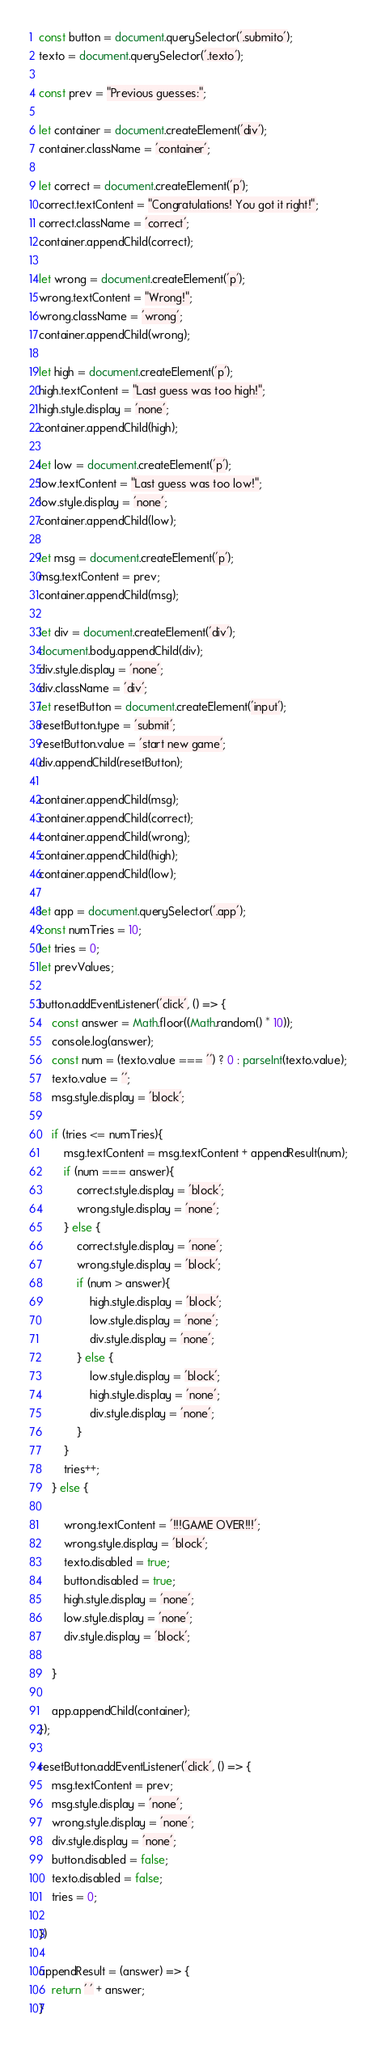<code> <loc_0><loc_0><loc_500><loc_500><_JavaScript_>
const button = document.querySelector('.submito');
texto = document.querySelector('.texto');

const prev = "Previous guesses:";

let container = document.createElement('div');
container.className = 'container';

let correct = document.createElement('p');
correct.textContent = "Congratulations! You got it right!";
correct.className = 'correct';
container.appendChild(correct);

let wrong = document.createElement('p');
wrong.textContent = "Wrong!";
wrong.className = 'wrong';
container.appendChild(wrong);

let high = document.createElement('p');
high.textContent = "Last guess was too high!";
high.style.display = 'none';
container.appendChild(high);

let low = document.createElement('p');
low.textContent = "Last guess was too low!";
low.style.display = 'none';
container.appendChild(low);

let msg = document.createElement('p');
msg.textContent = prev;
container.appendChild(msg);

let div = document.createElement('div');
document.body.appendChild(div);
div.style.display = 'none';
div.className = 'div';
let resetButton = document.createElement('input');
resetButton.type = 'submit';
resetButton.value = 'start new game';
div.appendChild(resetButton);

container.appendChild(msg);
container.appendChild(correct);
container.appendChild(wrong);
container.appendChild(high);
container.appendChild(low);

let app = document.querySelector('.app');
const numTries = 10;
let tries = 0;
let prevValues;

button.addEventListener('click', () => {
	const answer = Math.floor((Math.random() * 10));
	console.log(answer);
	const num = (texto.value === '') ? 0 : parseInt(texto.value);
	texto.value = '';
	msg.style.display = 'block';

	if (tries <= numTries){
		msg.textContent = msg.textContent + appendResult(num);
		if (num === answer){
			correct.style.display = 'block';
			wrong.style.display = 'none';
		} else {
			correct.style.display = 'none';
			wrong.style.display = 'block';
			if (num > answer){
				high.style.display = 'block';
				low.style.display = 'none';
				div.style.display = 'none';
			} else {
				low.style.display = 'block';
				high.style.display = 'none';
				div.style.display = 'none';
			}
		}
		tries++;
	} else {

		wrong.textContent = '!!!GAME OVER!!!';
		wrong.style.display = 'block';
		texto.disabled = true;
		button.disabled = true;
		high.style.display = 'none';
		low.style.display = 'none';
		div.style.display = 'block';
		
	}

  	app.appendChild(container);
});

resetButton.addEventListener('click', () => {
	msg.textContent = prev;
	msg.style.display = 'none';
	wrong.style.display = 'none';
	div.style.display = 'none';
	button.disabled = false;
	texto.disabled = false;
	tries = 0;

})

appendResult = (answer) => {
	return ' ' + answer;
}
</code> 